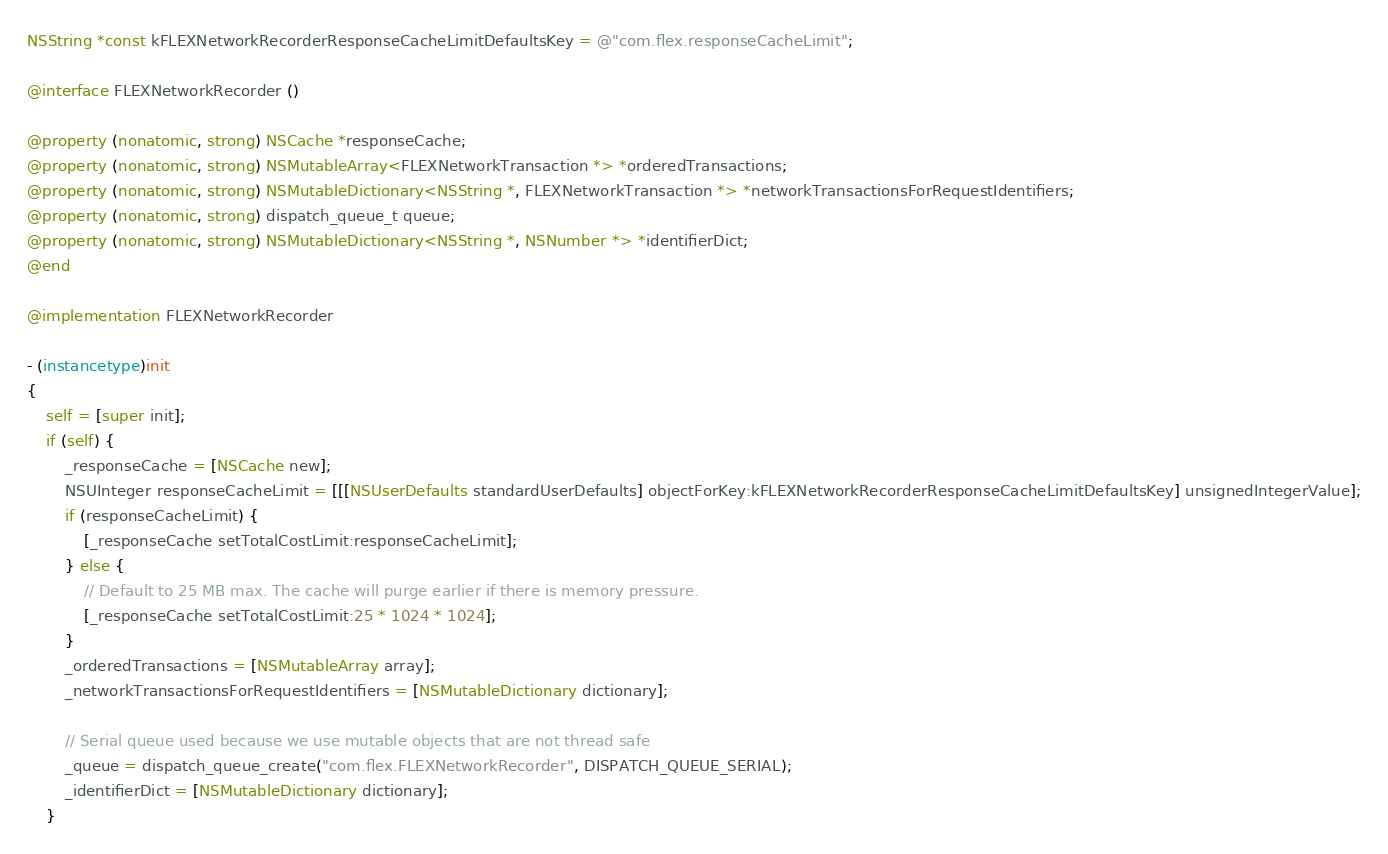Convert code to text. <code><loc_0><loc_0><loc_500><loc_500><_ObjectiveC_>NSString *const kFLEXNetworkRecorderResponseCacheLimitDefaultsKey = @"com.flex.responseCacheLimit";

@interface FLEXNetworkRecorder ()

@property (nonatomic, strong) NSCache *responseCache;
@property (nonatomic, strong) NSMutableArray<FLEXNetworkTransaction *> *orderedTransactions;
@property (nonatomic, strong) NSMutableDictionary<NSString *, FLEXNetworkTransaction *> *networkTransactionsForRequestIdentifiers;
@property (nonatomic, strong) dispatch_queue_t queue;
@property (nonatomic, strong) NSMutableDictionary<NSString *, NSNumber *> *identifierDict;
@end

@implementation FLEXNetworkRecorder

- (instancetype)init
{
    self = [super init];
    if (self) {
        _responseCache = [NSCache new];
        NSUInteger responseCacheLimit = [[[NSUserDefaults standardUserDefaults] objectForKey:kFLEXNetworkRecorderResponseCacheLimitDefaultsKey] unsignedIntegerValue];
        if (responseCacheLimit) {
            [_responseCache setTotalCostLimit:responseCacheLimit];
        } else {
            // Default to 25 MB max. The cache will purge earlier if there is memory pressure.
            [_responseCache setTotalCostLimit:25 * 1024 * 1024];
        }
        _orderedTransactions = [NSMutableArray array];
        _networkTransactionsForRequestIdentifiers = [NSMutableDictionary dictionary];

        // Serial queue used because we use mutable objects that are not thread safe
        _queue = dispatch_queue_create("com.flex.FLEXNetworkRecorder", DISPATCH_QUEUE_SERIAL);
        _identifierDict = [NSMutableDictionary dictionary];
    }</code> 